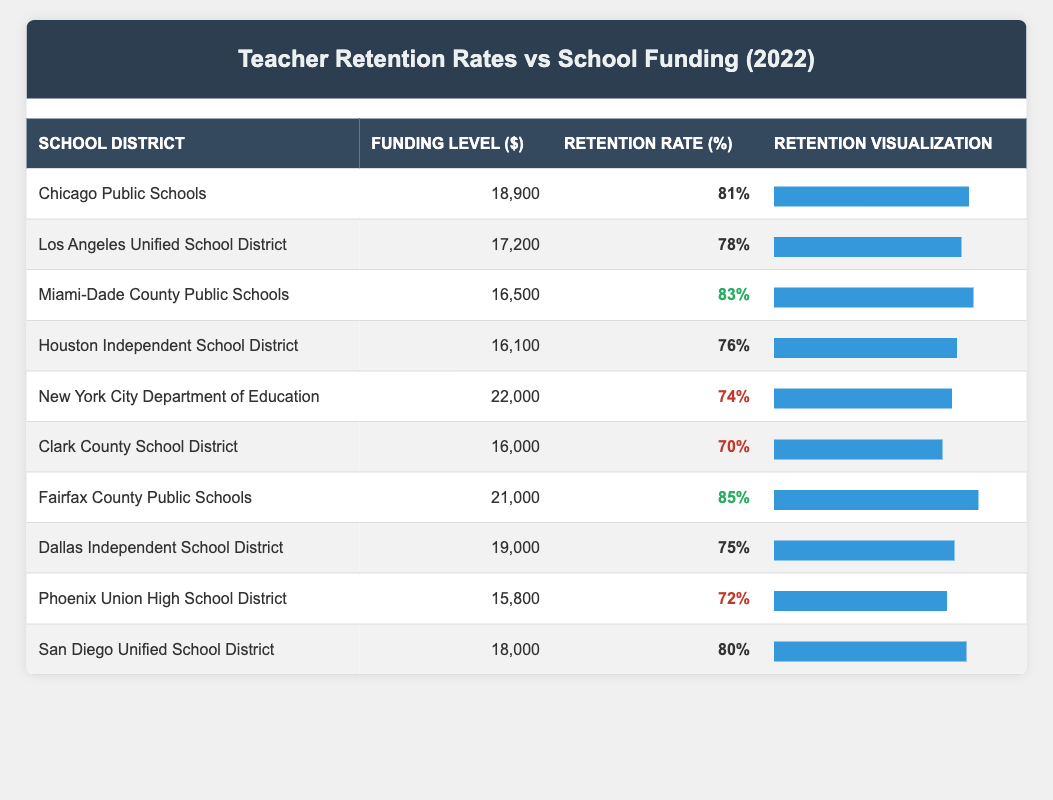What is the retention rate for Miami-Dade County Public Schools? The table shows that the retention rate for Miami-Dade County Public Schools is listed as 83%.
Answer: 83% Which school district has the highest funding level? The table lists the funding levels for all school districts, and New York City Department of Education has the highest funding level at $22,000.
Answer: $22,000 What is the average retention rate of the school districts listed? The retention rates are 81, 78, 83, 76, 74, 70, 85, 75, 72, and 80. Adding these rates gives  81 + 78 + 83 + 76 + 74 + 70 + 85 + 75 + 72 + 80 =  804. Dividing by the number of school districts (10), the average retention rate is 804 / 10 = 80.4%.
Answer: 80.4% Is the retention rate higher than 80% for Fairfax County Public Schools? The table indicates that the retention rate for Fairfax County Public Schools is 85%, which is indeed higher than 80%.
Answer: Yes Which school district has a lower retention rate: Los Angeles Unified School District or Houston Independent School District? The table shows Los Angeles Unified School District with a retention rate of 78% and Houston Independent School District with a retention rate of 76%. Since 78% is greater than 76%, Houston Independent School District has the lower retention rate.
Answer: Houston Independent School District What is the difference in funding levels between Clark County School District and San Diego Unified School District? Clark County School District has a funding level of $16,000 and San Diego Unified School District has a funding level of $18,000. The difference is calculated as $18,000 - $16,000 = $2,000.
Answer: $2,000 Are there any school districts with a retention rate lower than 75%? The retention rates listed are 81, 78, 83, 76, 74, 70, 85, 75, 72, and 80. Clark County School District (70%) and Phoenix Union High School District (72%) have retention rates lower than 75%.
Answer: Yes What percentage of the school districts have a retention rate above 75%? The retention rates above 75% are 81, 78, 83, 76, 85, and 80, which are 6 out of 10 districts. The percentage is (6/10) * 100 = 60%.
Answer: 60% 